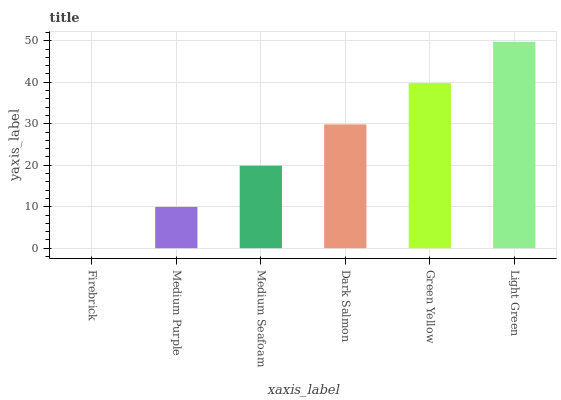Is Firebrick the minimum?
Answer yes or no. Yes. Is Light Green the maximum?
Answer yes or no. Yes. Is Medium Purple the minimum?
Answer yes or no. No. Is Medium Purple the maximum?
Answer yes or no. No. Is Medium Purple greater than Firebrick?
Answer yes or no. Yes. Is Firebrick less than Medium Purple?
Answer yes or no. Yes. Is Firebrick greater than Medium Purple?
Answer yes or no. No. Is Medium Purple less than Firebrick?
Answer yes or no. No. Is Dark Salmon the high median?
Answer yes or no. Yes. Is Medium Seafoam the low median?
Answer yes or no. Yes. Is Firebrick the high median?
Answer yes or no. No. Is Firebrick the low median?
Answer yes or no. No. 